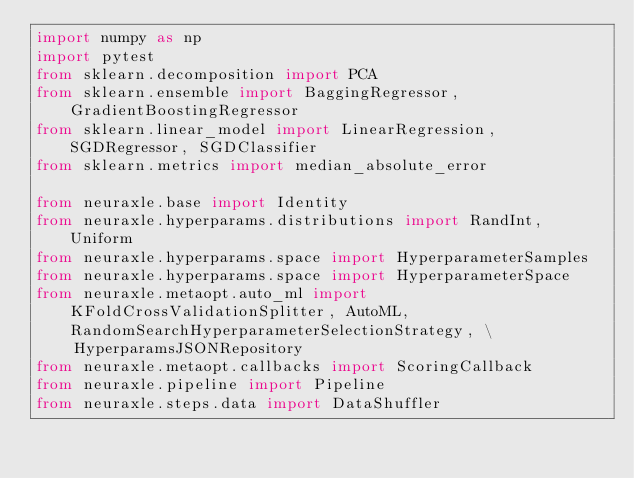<code> <loc_0><loc_0><loc_500><loc_500><_Python_>import numpy as np
import pytest
from sklearn.decomposition import PCA
from sklearn.ensemble import BaggingRegressor, GradientBoostingRegressor
from sklearn.linear_model import LinearRegression, SGDRegressor, SGDClassifier
from sklearn.metrics import median_absolute_error

from neuraxle.base import Identity
from neuraxle.hyperparams.distributions import RandInt, Uniform
from neuraxle.hyperparams.space import HyperparameterSamples
from neuraxle.hyperparams.space import HyperparameterSpace
from neuraxle.metaopt.auto_ml import KFoldCrossValidationSplitter, AutoML, RandomSearchHyperparameterSelectionStrategy, \
    HyperparamsJSONRepository
from neuraxle.metaopt.callbacks import ScoringCallback
from neuraxle.pipeline import Pipeline
from neuraxle.steps.data import DataShuffler</code> 